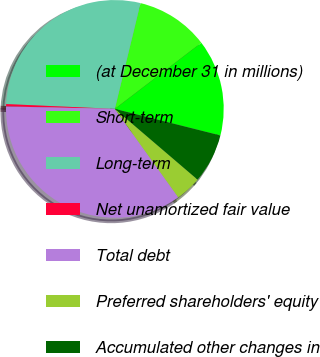Convert chart. <chart><loc_0><loc_0><loc_500><loc_500><pie_chart><fcel>(at December 31 in millions)<fcel>Short-term<fcel>Long-term<fcel>Net unamortized fair value<fcel>Total debt<fcel>Preferred shareholders' equity<fcel>Accumulated other changes in<nl><fcel>14.31%<fcel>10.82%<fcel>28.08%<fcel>0.35%<fcel>35.25%<fcel>3.84%<fcel>7.33%<nl></chart> 